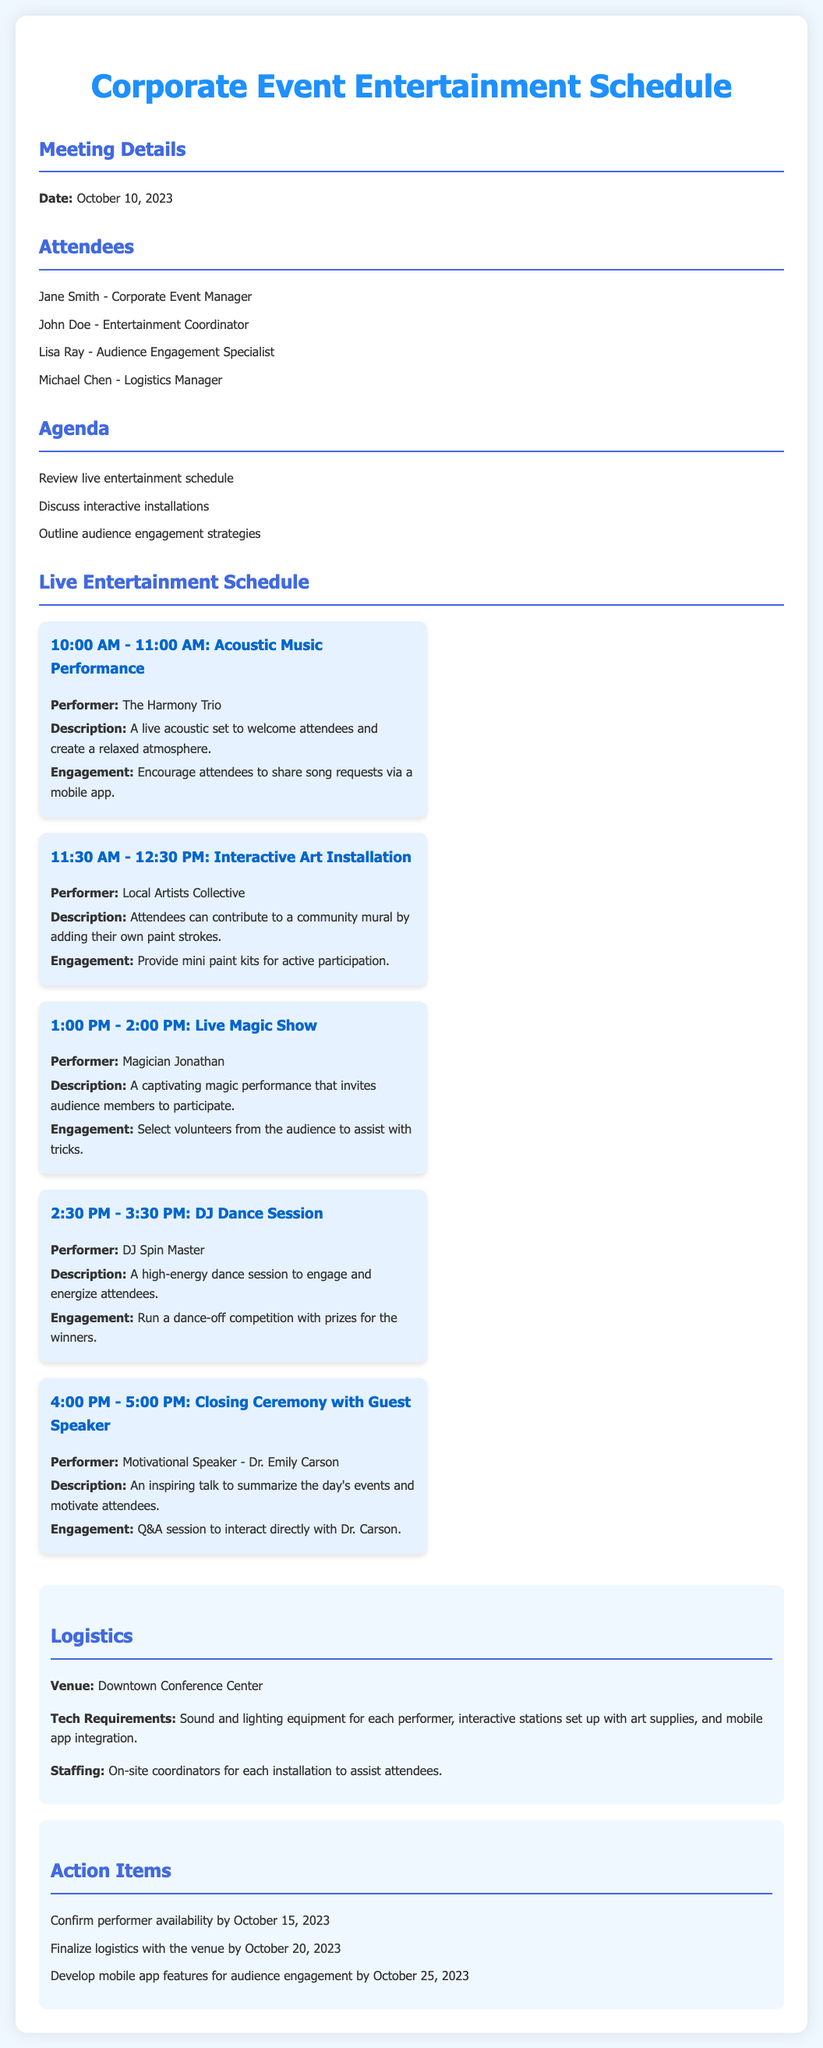What time does the acoustic music performance start? The schedule shows that the acoustic music performance starts at 10:00 AM.
Answer: 10:00 AM Who is the performer for the DJ dance session? The document lists DJ Spin Master as the performer for the DJ dance session.
Answer: DJ Spin Master What engagement strategy is used during the live magic show? The document mentions selecting volunteers from the audience to assist with tricks as the engagement strategy.
Answer: Select volunteers How long is the interactive art installation scheduled for? The installation is scheduled for one hour, from 11:30 AM to 12:30 PM.
Answer: One hour What is the venue for the event? The logistics section specifies Downtown Conference Center as the venue.
Answer: Downtown Conference Center What date is the confirmation of performer availability due? The action items state that confirmation of performer availability is due by October 15, 2023.
Answer: October 15, 2023 Which performer offers a closing ceremony with a motivational talk? The document identifies Dr. Emily Carson as the motivational speaker for the closing ceremony.
Answer: Dr. Emily Carson What item is provided for audience participation in the interactive art installation? The document mentions providing mini paint kits for active participation in the art installation.
Answer: Mini paint kits 